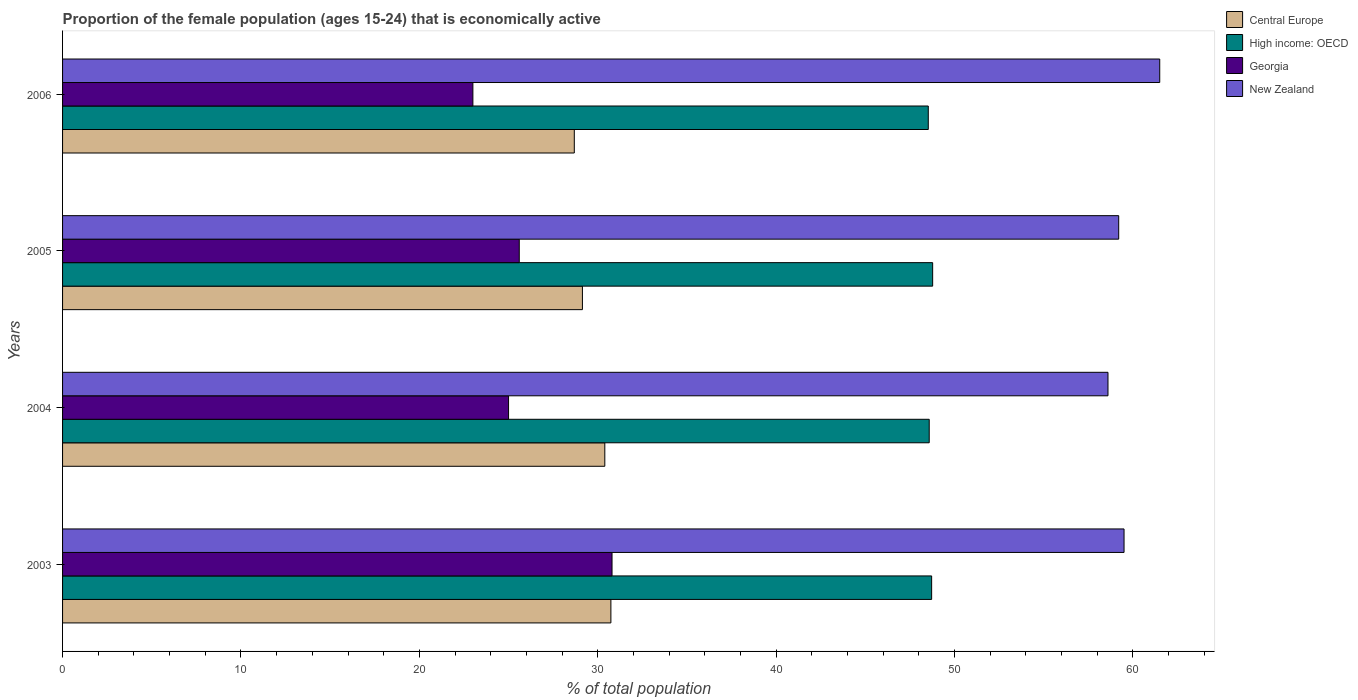How many different coloured bars are there?
Offer a very short reply. 4. Are the number of bars on each tick of the Y-axis equal?
Make the answer very short. Yes. How many bars are there on the 3rd tick from the top?
Provide a short and direct response. 4. How many bars are there on the 3rd tick from the bottom?
Provide a short and direct response. 4. What is the label of the 4th group of bars from the top?
Provide a short and direct response. 2003. Across all years, what is the maximum proportion of the female population that is economically active in High income: OECD?
Provide a short and direct response. 48.77. Across all years, what is the minimum proportion of the female population that is economically active in Central Europe?
Your answer should be compact. 28.68. In which year was the proportion of the female population that is economically active in High income: OECD maximum?
Your answer should be very brief. 2005. In which year was the proportion of the female population that is economically active in Georgia minimum?
Offer a terse response. 2006. What is the total proportion of the female population that is economically active in New Zealand in the graph?
Provide a short and direct response. 238.8. What is the difference between the proportion of the female population that is economically active in New Zealand in 2003 and that in 2005?
Your response must be concise. 0.3. What is the difference between the proportion of the female population that is economically active in Central Europe in 2006 and the proportion of the female population that is economically active in High income: OECD in 2003?
Offer a very short reply. -20.03. What is the average proportion of the female population that is economically active in New Zealand per year?
Offer a terse response. 59.7. In the year 2005, what is the difference between the proportion of the female population that is economically active in Central Europe and proportion of the female population that is economically active in New Zealand?
Your answer should be very brief. -30.06. What is the ratio of the proportion of the female population that is economically active in High income: OECD in 2004 to that in 2005?
Your response must be concise. 1. Is the proportion of the female population that is economically active in Central Europe in 2003 less than that in 2006?
Your answer should be very brief. No. What is the difference between the highest and the second highest proportion of the female population that is economically active in High income: OECD?
Ensure brevity in your answer.  0.06. What is the difference between the highest and the lowest proportion of the female population that is economically active in New Zealand?
Your response must be concise. 2.9. In how many years, is the proportion of the female population that is economically active in New Zealand greater than the average proportion of the female population that is economically active in New Zealand taken over all years?
Offer a terse response. 1. What does the 2nd bar from the top in 2003 represents?
Your answer should be compact. Georgia. What does the 1st bar from the bottom in 2005 represents?
Give a very brief answer. Central Europe. How many bars are there?
Give a very brief answer. 16. What is the difference between two consecutive major ticks on the X-axis?
Offer a terse response. 10. Are the values on the major ticks of X-axis written in scientific E-notation?
Provide a short and direct response. No. Does the graph contain any zero values?
Your answer should be compact. No. How many legend labels are there?
Provide a short and direct response. 4. How are the legend labels stacked?
Your answer should be very brief. Vertical. What is the title of the graph?
Keep it short and to the point. Proportion of the female population (ages 15-24) that is economically active. What is the label or title of the X-axis?
Provide a succinct answer. % of total population. What is the % of total population in Central Europe in 2003?
Ensure brevity in your answer.  30.74. What is the % of total population in High income: OECD in 2003?
Offer a very short reply. 48.71. What is the % of total population in Georgia in 2003?
Provide a succinct answer. 30.8. What is the % of total population of New Zealand in 2003?
Give a very brief answer. 59.5. What is the % of total population of Central Europe in 2004?
Ensure brevity in your answer.  30.39. What is the % of total population in High income: OECD in 2004?
Make the answer very short. 48.58. What is the % of total population in Georgia in 2004?
Your answer should be very brief. 25. What is the % of total population in New Zealand in 2004?
Ensure brevity in your answer.  58.6. What is the % of total population of Central Europe in 2005?
Provide a succinct answer. 29.14. What is the % of total population of High income: OECD in 2005?
Your answer should be compact. 48.77. What is the % of total population of Georgia in 2005?
Your answer should be very brief. 25.6. What is the % of total population of New Zealand in 2005?
Your response must be concise. 59.2. What is the % of total population in Central Europe in 2006?
Provide a succinct answer. 28.68. What is the % of total population in High income: OECD in 2006?
Your answer should be very brief. 48.53. What is the % of total population in Georgia in 2006?
Ensure brevity in your answer.  23. What is the % of total population in New Zealand in 2006?
Your response must be concise. 61.5. Across all years, what is the maximum % of total population in Central Europe?
Offer a terse response. 30.74. Across all years, what is the maximum % of total population of High income: OECD?
Your answer should be very brief. 48.77. Across all years, what is the maximum % of total population in Georgia?
Your answer should be very brief. 30.8. Across all years, what is the maximum % of total population in New Zealand?
Give a very brief answer. 61.5. Across all years, what is the minimum % of total population of Central Europe?
Your answer should be very brief. 28.68. Across all years, what is the minimum % of total population in High income: OECD?
Offer a very short reply. 48.53. Across all years, what is the minimum % of total population in New Zealand?
Make the answer very short. 58.6. What is the total % of total population of Central Europe in the graph?
Your response must be concise. 118.96. What is the total % of total population in High income: OECD in the graph?
Ensure brevity in your answer.  194.59. What is the total % of total population of Georgia in the graph?
Keep it short and to the point. 104.4. What is the total % of total population of New Zealand in the graph?
Provide a succinct answer. 238.8. What is the difference between the % of total population of Central Europe in 2003 and that in 2004?
Make the answer very short. 0.34. What is the difference between the % of total population in High income: OECD in 2003 and that in 2004?
Ensure brevity in your answer.  0.14. What is the difference between the % of total population in Central Europe in 2003 and that in 2005?
Provide a succinct answer. 1.6. What is the difference between the % of total population in High income: OECD in 2003 and that in 2005?
Provide a short and direct response. -0.06. What is the difference between the % of total population of Georgia in 2003 and that in 2005?
Your response must be concise. 5.2. What is the difference between the % of total population of Central Europe in 2003 and that in 2006?
Offer a terse response. 2.05. What is the difference between the % of total population of High income: OECD in 2003 and that in 2006?
Ensure brevity in your answer.  0.19. What is the difference between the % of total population in Georgia in 2003 and that in 2006?
Make the answer very short. 7.8. What is the difference between the % of total population of Central Europe in 2004 and that in 2005?
Provide a succinct answer. 1.25. What is the difference between the % of total population of High income: OECD in 2004 and that in 2005?
Ensure brevity in your answer.  -0.19. What is the difference between the % of total population of New Zealand in 2004 and that in 2005?
Keep it short and to the point. -0.6. What is the difference between the % of total population of Central Europe in 2004 and that in 2006?
Your answer should be very brief. 1.71. What is the difference between the % of total population of High income: OECD in 2004 and that in 2006?
Keep it short and to the point. 0.05. What is the difference between the % of total population in Central Europe in 2005 and that in 2006?
Ensure brevity in your answer.  0.46. What is the difference between the % of total population in High income: OECD in 2005 and that in 2006?
Your answer should be very brief. 0.25. What is the difference between the % of total population in New Zealand in 2005 and that in 2006?
Your response must be concise. -2.3. What is the difference between the % of total population of Central Europe in 2003 and the % of total population of High income: OECD in 2004?
Keep it short and to the point. -17.84. What is the difference between the % of total population in Central Europe in 2003 and the % of total population in Georgia in 2004?
Your response must be concise. 5.74. What is the difference between the % of total population in Central Europe in 2003 and the % of total population in New Zealand in 2004?
Offer a very short reply. -27.86. What is the difference between the % of total population of High income: OECD in 2003 and the % of total population of Georgia in 2004?
Ensure brevity in your answer.  23.71. What is the difference between the % of total population of High income: OECD in 2003 and the % of total population of New Zealand in 2004?
Make the answer very short. -9.89. What is the difference between the % of total population in Georgia in 2003 and the % of total population in New Zealand in 2004?
Give a very brief answer. -27.8. What is the difference between the % of total population in Central Europe in 2003 and the % of total population in High income: OECD in 2005?
Offer a terse response. -18.04. What is the difference between the % of total population of Central Europe in 2003 and the % of total population of Georgia in 2005?
Your response must be concise. 5.14. What is the difference between the % of total population in Central Europe in 2003 and the % of total population in New Zealand in 2005?
Offer a very short reply. -28.46. What is the difference between the % of total population in High income: OECD in 2003 and the % of total population in Georgia in 2005?
Keep it short and to the point. 23.11. What is the difference between the % of total population in High income: OECD in 2003 and the % of total population in New Zealand in 2005?
Your response must be concise. -10.49. What is the difference between the % of total population of Georgia in 2003 and the % of total population of New Zealand in 2005?
Offer a very short reply. -28.4. What is the difference between the % of total population of Central Europe in 2003 and the % of total population of High income: OECD in 2006?
Ensure brevity in your answer.  -17.79. What is the difference between the % of total population of Central Europe in 2003 and the % of total population of Georgia in 2006?
Offer a terse response. 7.74. What is the difference between the % of total population of Central Europe in 2003 and the % of total population of New Zealand in 2006?
Your answer should be compact. -30.76. What is the difference between the % of total population in High income: OECD in 2003 and the % of total population in Georgia in 2006?
Offer a terse response. 25.71. What is the difference between the % of total population in High income: OECD in 2003 and the % of total population in New Zealand in 2006?
Make the answer very short. -12.79. What is the difference between the % of total population in Georgia in 2003 and the % of total population in New Zealand in 2006?
Provide a succinct answer. -30.7. What is the difference between the % of total population of Central Europe in 2004 and the % of total population of High income: OECD in 2005?
Provide a succinct answer. -18.38. What is the difference between the % of total population in Central Europe in 2004 and the % of total population in Georgia in 2005?
Your response must be concise. 4.79. What is the difference between the % of total population in Central Europe in 2004 and the % of total population in New Zealand in 2005?
Your answer should be compact. -28.81. What is the difference between the % of total population in High income: OECD in 2004 and the % of total population in Georgia in 2005?
Provide a short and direct response. 22.98. What is the difference between the % of total population in High income: OECD in 2004 and the % of total population in New Zealand in 2005?
Provide a short and direct response. -10.62. What is the difference between the % of total population in Georgia in 2004 and the % of total population in New Zealand in 2005?
Give a very brief answer. -34.2. What is the difference between the % of total population in Central Europe in 2004 and the % of total population in High income: OECD in 2006?
Keep it short and to the point. -18.13. What is the difference between the % of total population in Central Europe in 2004 and the % of total population in Georgia in 2006?
Give a very brief answer. 7.39. What is the difference between the % of total population of Central Europe in 2004 and the % of total population of New Zealand in 2006?
Keep it short and to the point. -31.11. What is the difference between the % of total population in High income: OECD in 2004 and the % of total population in Georgia in 2006?
Your answer should be compact. 25.58. What is the difference between the % of total population of High income: OECD in 2004 and the % of total population of New Zealand in 2006?
Make the answer very short. -12.92. What is the difference between the % of total population in Georgia in 2004 and the % of total population in New Zealand in 2006?
Ensure brevity in your answer.  -36.5. What is the difference between the % of total population of Central Europe in 2005 and the % of total population of High income: OECD in 2006?
Offer a terse response. -19.39. What is the difference between the % of total population of Central Europe in 2005 and the % of total population of Georgia in 2006?
Keep it short and to the point. 6.14. What is the difference between the % of total population in Central Europe in 2005 and the % of total population in New Zealand in 2006?
Keep it short and to the point. -32.36. What is the difference between the % of total population in High income: OECD in 2005 and the % of total population in Georgia in 2006?
Keep it short and to the point. 25.77. What is the difference between the % of total population of High income: OECD in 2005 and the % of total population of New Zealand in 2006?
Give a very brief answer. -12.73. What is the difference between the % of total population in Georgia in 2005 and the % of total population in New Zealand in 2006?
Provide a succinct answer. -35.9. What is the average % of total population in Central Europe per year?
Ensure brevity in your answer.  29.74. What is the average % of total population of High income: OECD per year?
Give a very brief answer. 48.65. What is the average % of total population of Georgia per year?
Give a very brief answer. 26.1. What is the average % of total population in New Zealand per year?
Make the answer very short. 59.7. In the year 2003, what is the difference between the % of total population in Central Europe and % of total population in High income: OECD?
Offer a very short reply. -17.98. In the year 2003, what is the difference between the % of total population in Central Europe and % of total population in Georgia?
Provide a short and direct response. -0.06. In the year 2003, what is the difference between the % of total population in Central Europe and % of total population in New Zealand?
Provide a succinct answer. -28.76. In the year 2003, what is the difference between the % of total population in High income: OECD and % of total population in Georgia?
Your answer should be very brief. 17.91. In the year 2003, what is the difference between the % of total population in High income: OECD and % of total population in New Zealand?
Offer a terse response. -10.79. In the year 2003, what is the difference between the % of total population of Georgia and % of total population of New Zealand?
Offer a very short reply. -28.7. In the year 2004, what is the difference between the % of total population in Central Europe and % of total population in High income: OECD?
Provide a short and direct response. -18.18. In the year 2004, what is the difference between the % of total population of Central Europe and % of total population of Georgia?
Your answer should be very brief. 5.39. In the year 2004, what is the difference between the % of total population in Central Europe and % of total population in New Zealand?
Provide a succinct answer. -28.21. In the year 2004, what is the difference between the % of total population of High income: OECD and % of total population of Georgia?
Your response must be concise. 23.58. In the year 2004, what is the difference between the % of total population in High income: OECD and % of total population in New Zealand?
Offer a very short reply. -10.02. In the year 2004, what is the difference between the % of total population in Georgia and % of total population in New Zealand?
Your answer should be very brief. -33.6. In the year 2005, what is the difference between the % of total population of Central Europe and % of total population of High income: OECD?
Give a very brief answer. -19.63. In the year 2005, what is the difference between the % of total population in Central Europe and % of total population in Georgia?
Give a very brief answer. 3.54. In the year 2005, what is the difference between the % of total population of Central Europe and % of total population of New Zealand?
Provide a succinct answer. -30.06. In the year 2005, what is the difference between the % of total population of High income: OECD and % of total population of Georgia?
Your response must be concise. 23.17. In the year 2005, what is the difference between the % of total population of High income: OECD and % of total population of New Zealand?
Give a very brief answer. -10.43. In the year 2005, what is the difference between the % of total population of Georgia and % of total population of New Zealand?
Your answer should be compact. -33.6. In the year 2006, what is the difference between the % of total population of Central Europe and % of total population of High income: OECD?
Your answer should be very brief. -19.84. In the year 2006, what is the difference between the % of total population of Central Europe and % of total population of Georgia?
Provide a succinct answer. 5.68. In the year 2006, what is the difference between the % of total population of Central Europe and % of total population of New Zealand?
Offer a very short reply. -32.82. In the year 2006, what is the difference between the % of total population of High income: OECD and % of total population of Georgia?
Make the answer very short. 25.53. In the year 2006, what is the difference between the % of total population in High income: OECD and % of total population in New Zealand?
Provide a succinct answer. -12.97. In the year 2006, what is the difference between the % of total population of Georgia and % of total population of New Zealand?
Provide a succinct answer. -38.5. What is the ratio of the % of total population in Central Europe in 2003 to that in 2004?
Keep it short and to the point. 1.01. What is the ratio of the % of total population of Georgia in 2003 to that in 2004?
Keep it short and to the point. 1.23. What is the ratio of the % of total population in New Zealand in 2003 to that in 2004?
Provide a succinct answer. 1.02. What is the ratio of the % of total population of Central Europe in 2003 to that in 2005?
Give a very brief answer. 1.05. What is the ratio of the % of total population of High income: OECD in 2003 to that in 2005?
Your answer should be very brief. 1. What is the ratio of the % of total population in Georgia in 2003 to that in 2005?
Give a very brief answer. 1.2. What is the ratio of the % of total population of New Zealand in 2003 to that in 2005?
Your answer should be very brief. 1.01. What is the ratio of the % of total population of Central Europe in 2003 to that in 2006?
Your answer should be compact. 1.07. What is the ratio of the % of total population of Georgia in 2003 to that in 2006?
Your answer should be compact. 1.34. What is the ratio of the % of total population of New Zealand in 2003 to that in 2006?
Give a very brief answer. 0.97. What is the ratio of the % of total population of Central Europe in 2004 to that in 2005?
Provide a short and direct response. 1.04. What is the ratio of the % of total population of Georgia in 2004 to that in 2005?
Make the answer very short. 0.98. What is the ratio of the % of total population of New Zealand in 2004 to that in 2005?
Keep it short and to the point. 0.99. What is the ratio of the % of total population in Central Europe in 2004 to that in 2006?
Offer a very short reply. 1.06. What is the ratio of the % of total population of Georgia in 2004 to that in 2006?
Your answer should be very brief. 1.09. What is the ratio of the % of total population in New Zealand in 2004 to that in 2006?
Make the answer very short. 0.95. What is the ratio of the % of total population in Central Europe in 2005 to that in 2006?
Offer a terse response. 1.02. What is the ratio of the % of total population of Georgia in 2005 to that in 2006?
Offer a very short reply. 1.11. What is the ratio of the % of total population in New Zealand in 2005 to that in 2006?
Offer a terse response. 0.96. What is the difference between the highest and the second highest % of total population of Central Europe?
Give a very brief answer. 0.34. What is the difference between the highest and the second highest % of total population of High income: OECD?
Your response must be concise. 0.06. What is the difference between the highest and the second highest % of total population of Georgia?
Give a very brief answer. 5.2. What is the difference between the highest and the second highest % of total population in New Zealand?
Give a very brief answer. 2. What is the difference between the highest and the lowest % of total population of Central Europe?
Your answer should be compact. 2.05. What is the difference between the highest and the lowest % of total population in High income: OECD?
Keep it short and to the point. 0.25. 